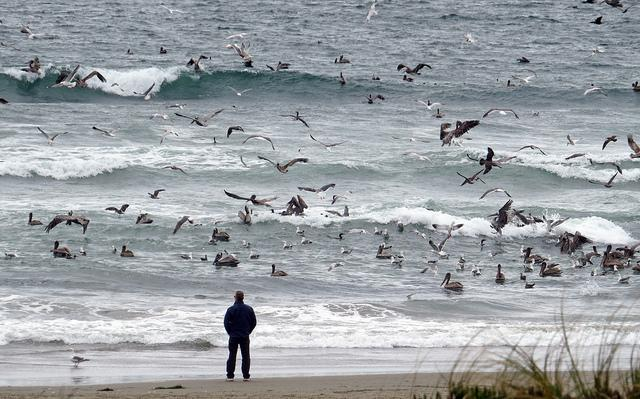What type of body of water are all of the birds gathering at?

Choices:
A) swamp
B) lake
C) pond
D) sea sea 